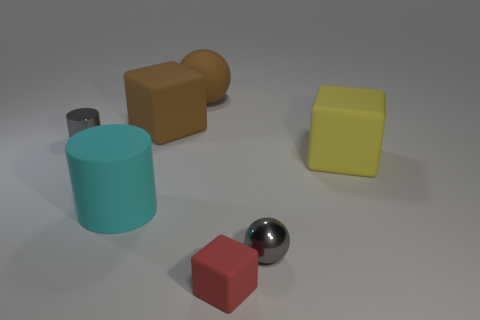Subtract all large blocks. How many blocks are left? 1 Subtract 1 blocks. How many blocks are left? 2 Add 2 purple matte blocks. How many objects exist? 9 Subtract all cylinders. How many objects are left? 5 Add 7 metal objects. How many metal objects are left? 9 Add 6 gray things. How many gray things exist? 8 Subtract 1 yellow blocks. How many objects are left? 6 Subtract all brown metal balls. Subtract all large brown rubber blocks. How many objects are left? 6 